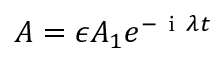<formula> <loc_0><loc_0><loc_500><loc_500>A = \epsilon A _ { 1 } e ^ { - i \lambda t }</formula> 